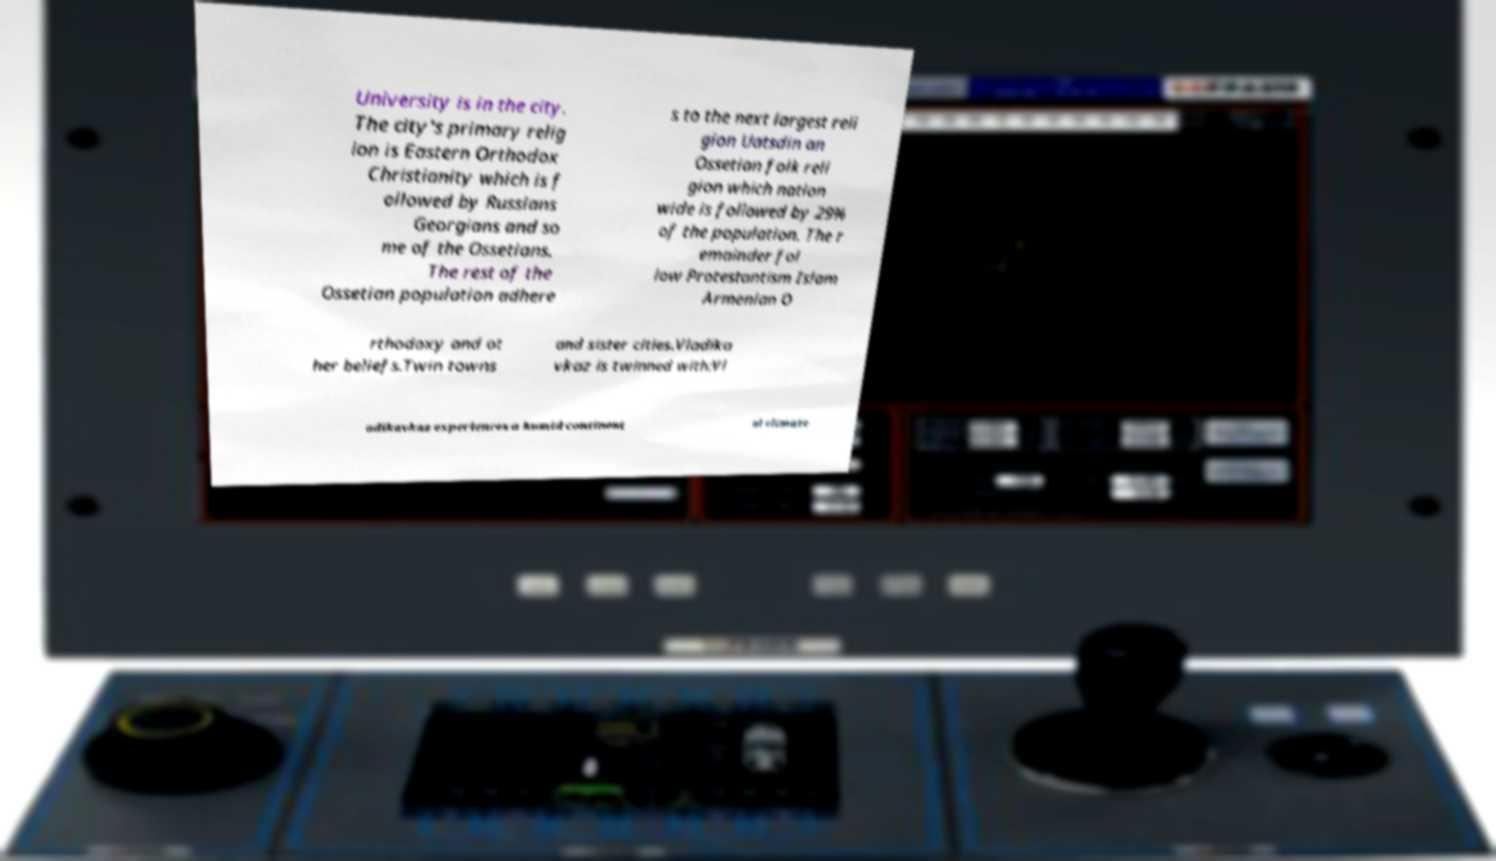For documentation purposes, I need the text within this image transcribed. Could you provide that? University is in the city. The city's primary relig ion is Eastern Orthodox Christianity which is f ollowed by Russians Georgians and so me of the Ossetians. The rest of the Ossetian population adhere s to the next largest reli gion Uatsdin an Ossetian folk reli gion which nation wide is followed by 29% of the population. The r emainder fol low Protestantism Islam Armenian O rthodoxy and ot her beliefs.Twin towns and sister cities.Vladika vkaz is twinned with:Vl adikavkaz experiences a humid continent al climate 